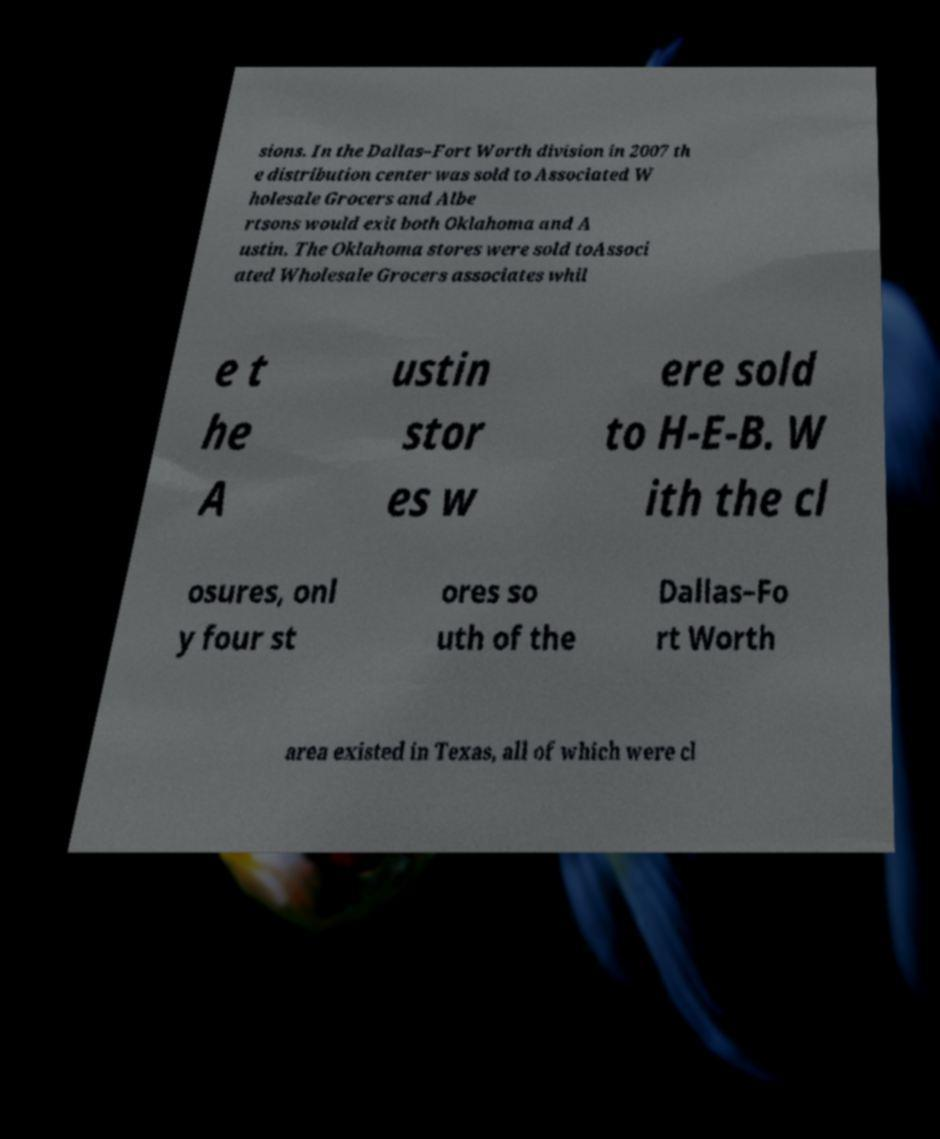Please identify and transcribe the text found in this image. sions. In the Dallas–Fort Worth division in 2007 th e distribution center was sold to Associated W holesale Grocers and Albe rtsons would exit both Oklahoma and A ustin. The Oklahoma stores were sold toAssoci ated Wholesale Grocers associates whil e t he A ustin stor es w ere sold to H-E-B. W ith the cl osures, onl y four st ores so uth of the Dallas–Fo rt Worth area existed in Texas, all of which were cl 